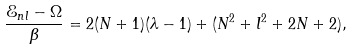Convert formula to latex. <formula><loc_0><loc_0><loc_500><loc_500>\frac { \mathcal { E } _ { n l } - \Omega } { \beta } = 2 ( N + 1 ) ( \lambda - 1 ) + ( N ^ { 2 } + l ^ { 2 } + 2 N + 2 ) ,</formula> 